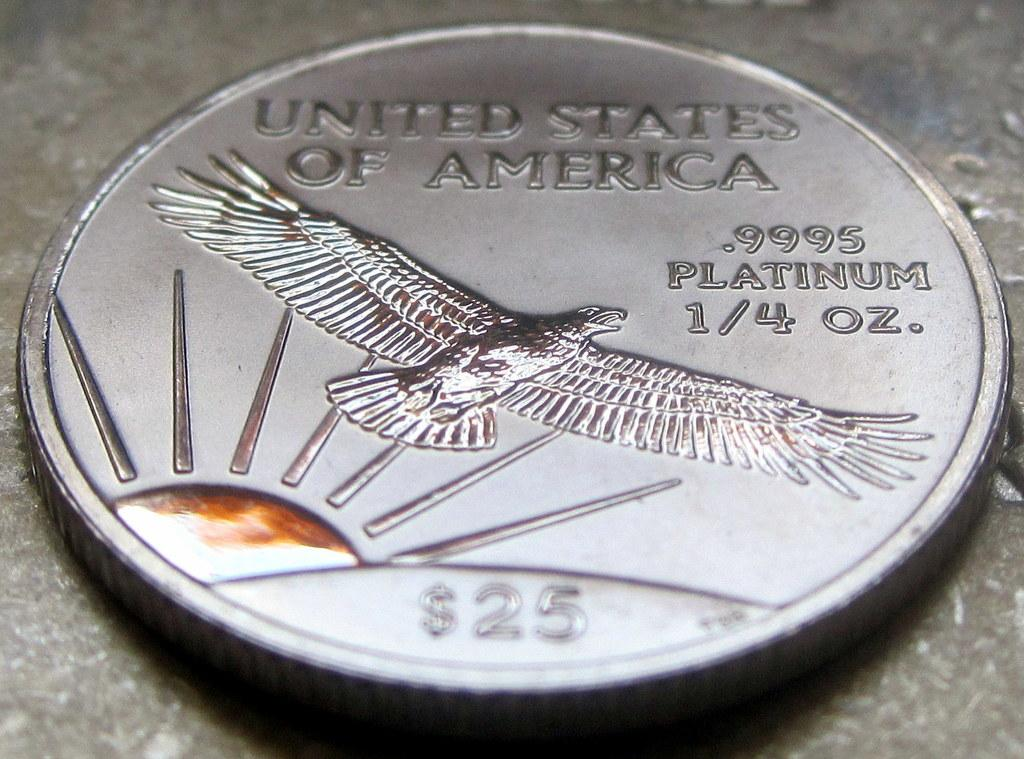<image>
Summarize the visual content of the image. A silver coin says  United States of America, .9995 Platinum 1/4 oz., $25, and has a picture of a rising sun and a bird. 